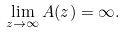Convert formula to latex. <formula><loc_0><loc_0><loc_500><loc_500>\lim _ { z \to \infty } A ( z ) = \infty .</formula> 